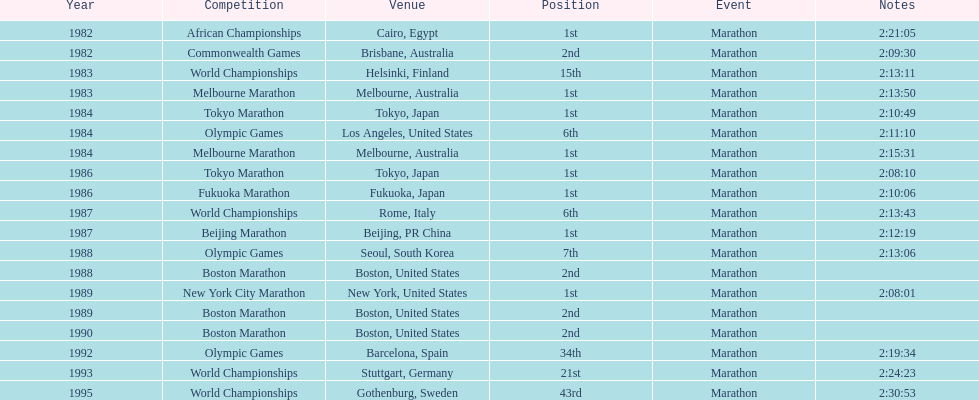What is the count of occasions when the venue was found in the united states? 5. 